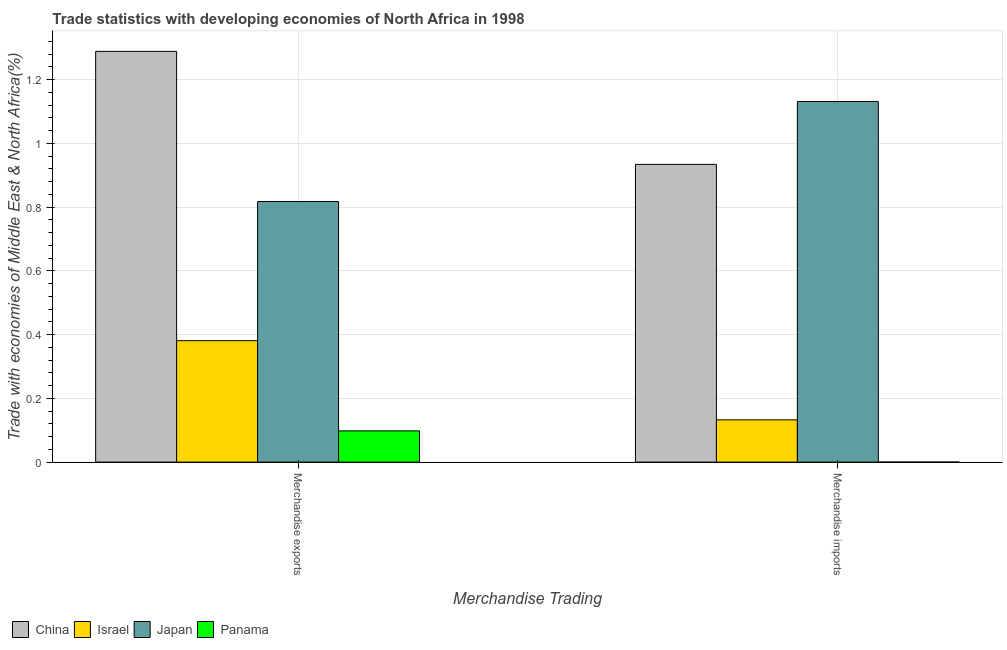How many groups of bars are there?
Ensure brevity in your answer.  2. Are the number of bars per tick equal to the number of legend labels?
Your answer should be compact. Yes. Are the number of bars on each tick of the X-axis equal?
Your answer should be compact. Yes. How many bars are there on the 2nd tick from the right?
Keep it short and to the point. 4. What is the label of the 1st group of bars from the left?
Your response must be concise. Merchandise exports. What is the merchandise imports in Israel?
Provide a short and direct response. 0.13. Across all countries, what is the maximum merchandise imports?
Keep it short and to the point. 1.13. Across all countries, what is the minimum merchandise imports?
Your answer should be very brief. 0. In which country was the merchandise exports minimum?
Provide a short and direct response. Panama. What is the total merchandise imports in the graph?
Your response must be concise. 2.2. What is the difference between the merchandise imports in Japan and that in Israel?
Your response must be concise. 1. What is the difference between the merchandise exports in China and the merchandise imports in Israel?
Make the answer very short. 1.16. What is the average merchandise exports per country?
Ensure brevity in your answer.  0.65. What is the difference between the merchandise exports and merchandise imports in Israel?
Ensure brevity in your answer.  0.25. In how many countries, is the merchandise exports greater than 0.52 %?
Provide a short and direct response. 2. What is the ratio of the merchandise imports in Israel to that in China?
Your answer should be compact. 0.14. In how many countries, is the merchandise exports greater than the average merchandise exports taken over all countries?
Provide a succinct answer. 2. How many bars are there?
Offer a very short reply. 8. What is the difference between two consecutive major ticks on the Y-axis?
Make the answer very short. 0.2. How many legend labels are there?
Offer a terse response. 4. How are the legend labels stacked?
Your response must be concise. Horizontal. What is the title of the graph?
Give a very brief answer. Trade statistics with developing economies of North Africa in 1998. What is the label or title of the X-axis?
Make the answer very short. Merchandise Trading. What is the label or title of the Y-axis?
Provide a short and direct response. Trade with economies of Middle East & North Africa(%). What is the Trade with economies of Middle East & North Africa(%) of China in Merchandise exports?
Your response must be concise. 1.29. What is the Trade with economies of Middle East & North Africa(%) in Israel in Merchandise exports?
Your answer should be compact. 0.38. What is the Trade with economies of Middle East & North Africa(%) of Japan in Merchandise exports?
Your answer should be very brief. 0.82. What is the Trade with economies of Middle East & North Africa(%) in Panama in Merchandise exports?
Your answer should be very brief. 0.1. What is the Trade with economies of Middle East & North Africa(%) in China in Merchandise imports?
Provide a short and direct response. 0.93. What is the Trade with economies of Middle East & North Africa(%) in Israel in Merchandise imports?
Make the answer very short. 0.13. What is the Trade with economies of Middle East & North Africa(%) in Japan in Merchandise imports?
Make the answer very short. 1.13. What is the Trade with economies of Middle East & North Africa(%) in Panama in Merchandise imports?
Offer a very short reply. 0. Across all Merchandise Trading, what is the maximum Trade with economies of Middle East & North Africa(%) of China?
Your response must be concise. 1.29. Across all Merchandise Trading, what is the maximum Trade with economies of Middle East & North Africa(%) of Israel?
Provide a short and direct response. 0.38. Across all Merchandise Trading, what is the maximum Trade with economies of Middle East & North Africa(%) of Japan?
Offer a very short reply. 1.13. Across all Merchandise Trading, what is the maximum Trade with economies of Middle East & North Africa(%) in Panama?
Ensure brevity in your answer.  0.1. Across all Merchandise Trading, what is the minimum Trade with economies of Middle East & North Africa(%) in China?
Your response must be concise. 0.93. Across all Merchandise Trading, what is the minimum Trade with economies of Middle East & North Africa(%) in Israel?
Make the answer very short. 0.13. Across all Merchandise Trading, what is the minimum Trade with economies of Middle East & North Africa(%) of Japan?
Offer a terse response. 0.82. Across all Merchandise Trading, what is the minimum Trade with economies of Middle East & North Africa(%) in Panama?
Give a very brief answer. 0. What is the total Trade with economies of Middle East & North Africa(%) in China in the graph?
Offer a very short reply. 2.22. What is the total Trade with economies of Middle East & North Africa(%) in Israel in the graph?
Ensure brevity in your answer.  0.51. What is the total Trade with economies of Middle East & North Africa(%) of Japan in the graph?
Your answer should be compact. 1.95. What is the total Trade with economies of Middle East & North Africa(%) of Panama in the graph?
Your answer should be compact. 0.1. What is the difference between the Trade with economies of Middle East & North Africa(%) of China in Merchandise exports and that in Merchandise imports?
Ensure brevity in your answer.  0.35. What is the difference between the Trade with economies of Middle East & North Africa(%) in Israel in Merchandise exports and that in Merchandise imports?
Offer a very short reply. 0.25. What is the difference between the Trade with economies of Middle East & North Africa(%) of Japan in Merchandise exports and that in Merchandise imports?
Your response must be concise. -0.31. What is the difference between the Trade with economies of Middle East & North Africa(%) in Panama in Merchandise exports and that in Merchandise imports?
Your answer should be very brief. 0.1. What is the difference between the Trade with economies of Middle East & North Africa(%) of China in Merchandise exports and the Trade with economies of Middle East & North Africa(%) of Israel in Merchandise imports?
Give a very brief answer. 1.16. What is the difference between the Trade with economies of Middle East & North Africa(%) in China in Merchandise exports and the Trade with economies of Middle East & North Africa(%) in Japan in Merchandise imports?
Your answer should be compact. 0.16. What is the difference between the Trade with economies of Middle East & North Africa(%) in China in Merchandise exports and the Trade with economies of Middle East & North Africa(%) in Panama in Merchandise imports?
Provide a short and direct response. 1.29. What is the difference between the Trade with economies of Middle East & North Africa(%) in Israel in Merchandise exports and the Trade with economies of Middle East & North Africa(%) in Japan in Merchandise imports?
Your answer should be very brief. -0.75. What is the difference between the Trade with economies of Middle East & North Africa(%) of Israel in Merchandise exports and the Trade with economies of Middle East & North Africa(%) of Panama in Merchandise imports?
Your answer should be compact. 0.38. What is the difference between the Trade with economies of Middle East & North Africa(%) of Japan in Merchandise exports and the Trade with economies of Middle East & North Africa(%) of Panama in Merchandise imports?
Offer a terse response. 0.82. What is the average Trade with economies of Middle East & North Africa(%) in China per Merchandise Trading?
Offer a very short reply. 1.11. What is the average Trade with economies of Middle East & North Africa(%) of Israel per Merchandise Trading?
Your answer should be compact. 0.26. What is the average Trade with economies of Middle East & North Africa(%) in Japan per Merchandise Trading?
Offer a very short reply. 0.97. What is the average Trade with economies of Middle East & North Africa(%) of Panama per Merchandise Trading?
Provide a short and direct response. 0.05. What is the difference between the Trade with economies of Middle East & North Africa(%) of China and Trade with economies of Middle East & North Africa(%) of Israel in Merchandise exports?
Offer a terse response. 0.91. What is the difference between the Trade with economies of Middle East & North Africa(%) of China and Trade with economies of Middle East & North Africa(%) of Japan in Merchandise exports?
Your answer should be very brief. 0.47. What is the difference between the Trade with economies of Middle East & North Africa(%) in China and Trade with economies of Middle East & North Africa(%) in Panama in Merchandise exports?
Give a very brief answer. 1.19. What is the difference between the Trade with economies of Middle East & North Africa(%) of Israel and Trade with economies of Middle East & North Africa(%) of Japan in Merchandise exports?
Provide a succinct answer. -0.44. What is the difference between the Trade with economies of Middle East & North Africa(%) in Israel and Trade with economies of Middle East & North Africa(%) in Panama in Merchandise exports?
Offer a very short reply. 0.28. What is the difference between the Trade with economies of Middle East & North Africa(%) of Japan and Trade with economies of Middle East & North Africa(%) of Panama in Merchandise exports?
Offer a very short reply. 0.72. What is the difference between the Trade with economies of Middle East & North Africa(%) of China and Trade with economies of Middle East & North Africa(%) of Israel in Merchandise imports?
Provide a short and direct response. 0.8. What is the difference between the Trade with economies of Middle East & North Africa(%) of China and Trade with economies of Middle East & North Africa(%) of Japan in Merchandise imports?
Your response must be concise. -0.2. What is the difference between the Trade with economies of Middle East & North Africa(%) in China and Trade with economies of Middle East & North Africa(%) in Panama in Merchandise imports?
Make the answer very short. 0.93. What is the difference between the Trade with economies of Middle East & North Africa(%) of Israel and Trade with economies of Middle East & North Africa(%) of Japan in Merchandise imports?
Provide a short and direct response. -1. What is the difference between the Trade with economies of Middle East & North Africa(%) of Israel and Trade with economies of Middle East & North Africa(%) of Panama in Merchandise imports?
Offer a terse response. 0.13. What is the difference between the Trade with economies of Middle East & North Africa(%) in Japan and Trade with economies of Middle East & North Africa(%) in Panama in Merchandise imports?
Your response must be concise. 1.13. What is the ratio of the Trade with economies of Middle East & North Africa(%) of China in Merchandise exports to that in Merchandise imports?
Give a very brief answer. 1.38. What is the ratio of the Trade with economies of Middle East & North Africa(%) in Israel in Merchandise exports to that in Merchandise imports?
Provide a succinct answer. 2.87. What is the ratio of the Trade with economies of Middle East & North Africa(%) of Japan in Merchandise exports to that in Merchandise imports?
Ensure brevity in your answer.  0.72. What is the ratio of the Trade with economies of Middle East & North Africa(%) in Panama in Merchandise exports to that in Merchandise imports?
Keep it short and to the point. 614.18. What is the difference between the highest and the second highest Trade with economies of Middle East & North Africa(%) in China?
Your answer should be compact. 0.35. What is the difference between the highest and the second highest Trade with economies of Middle East & North Africa(%) in Israel?
Offer a terse response. 0.25. What is the difference between the highest and the second highest Trade with economies of Middle East & North Africa(%) in Japan?
Your answer should be very brief. 0.31. What is the difference between the highest and the second highest Trade with economies of Middle East & North Africa(%) of Panama?
Your response must be concise. 0.1. What is the difference between the highest and the lowest Trade with economies of Middle East & North Africa(%) in China?
Give a very brief answer. 0.35. What is the difference between the highest and the lowest Trade with economies of Middle East & North Africa(%) in Israel?
Make the answer very short. 0.25. What is the difference between the highest and the lowest Trade with economies of Middle East & North Africa(%) in Japan?
Keep it short and to the point. 0.31. What is the difference between the highest and the lowest Trade with economies of Middle East & North Africa(%) in Panama?
Ensure brevity in your answer.  0.1. 